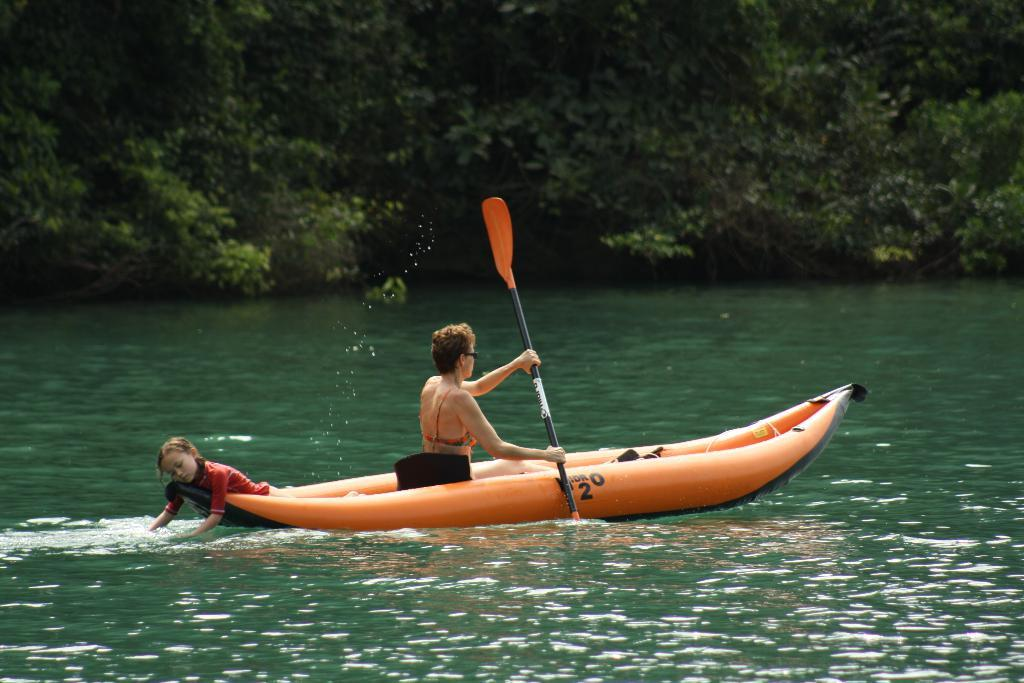Who is the main subject in the image? There is a woman in the image. What is the woman doing in the image? The woman is boating on the surface of the water. Are there any other people in the image? Yes, there is a girl in the image. What can be seen in the background of the image? There are trees in the background of the image. What type of table is being used by the woman while boating in the image? There is no table present in the image; the woman is boating on the surface of the water. 